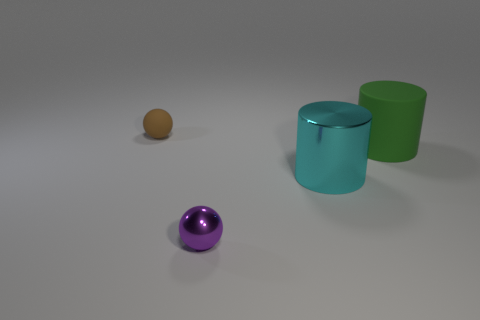Add 2 green matte objects. How many objects exist? 6 Subtract 2 spheres. How many spheres are left? 0 Subtract all cyan cubes. How many brown spheres are left? 1 Subtract all green cylinders. How many cylinders are left? 1 Subtract all big cylinders. Subtract all big objects. How many objects are left? 0 Add 4 small purple shiny objects. How many small purple shiny objects are left? 5 Add 2 brown spheres. How many brown spheres exist? 3 Subtract 0 purple blocks. How many objects are left? 4 Subtract all yellow cylinders. Subtract all green spheres. How many cylinders are left? 2 